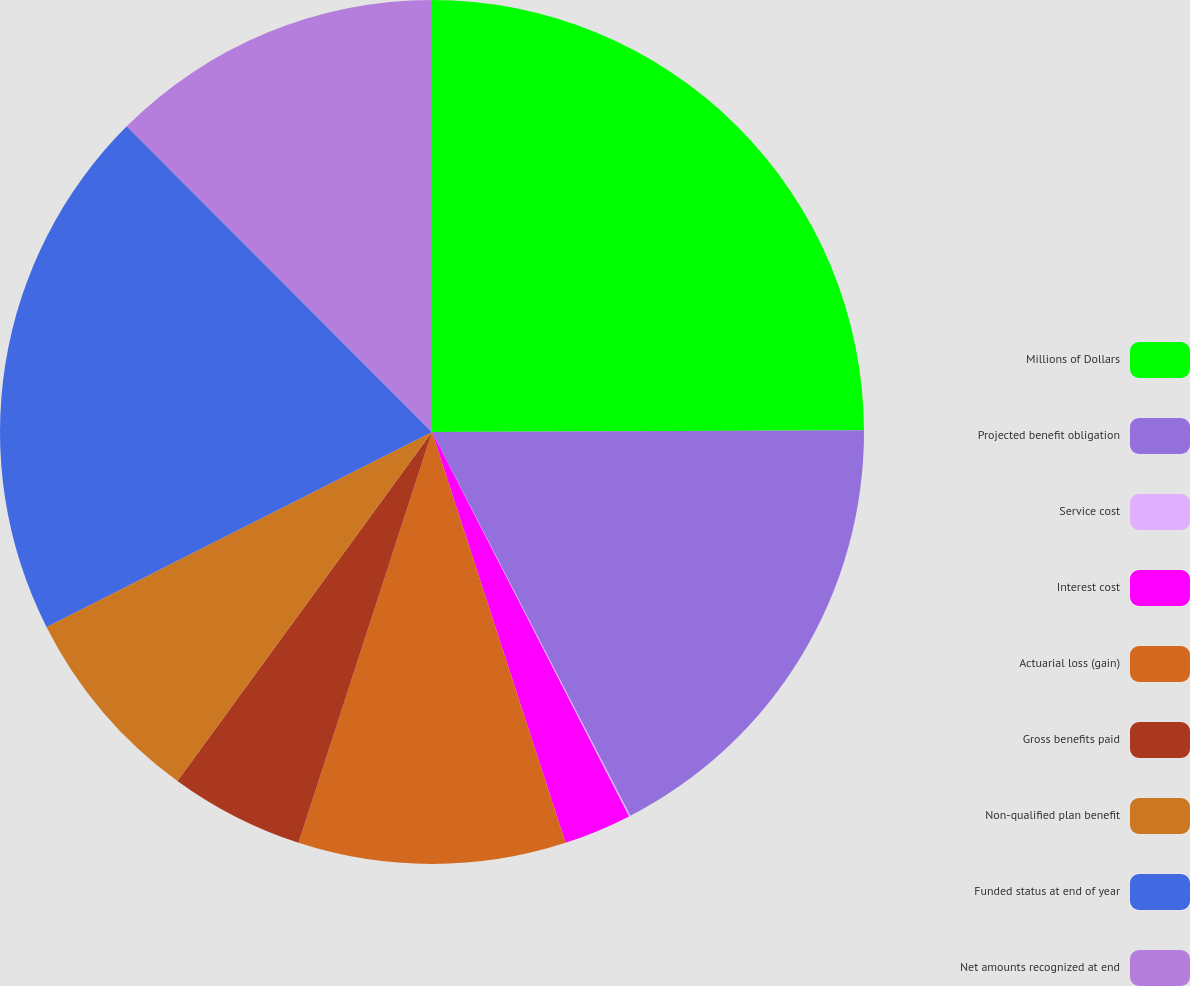Convert chart to OTSL. <chart><loc_0><loc_0><loc_500><loc_500><pie_chart><fcel>Millions of Dollars<fcel>Projected benefit obligation<fcel>Service cost<fcel>Interest cost<fcel>Actuarial loss (gain)<fcel>Gross benefits paid<fcel>Non-qualified plan benefit<fcel>Funded status at end of year<fcel>Net amounts recognized at end<nl><fcel>24.94%<fcel>17.47%<fcel>0.05%<fcel>2.54%<fcel>10.0%<fcel>5.03%<fcel>7.52%<fcel>19.96%<fcel>12.49%<nl></chart> 